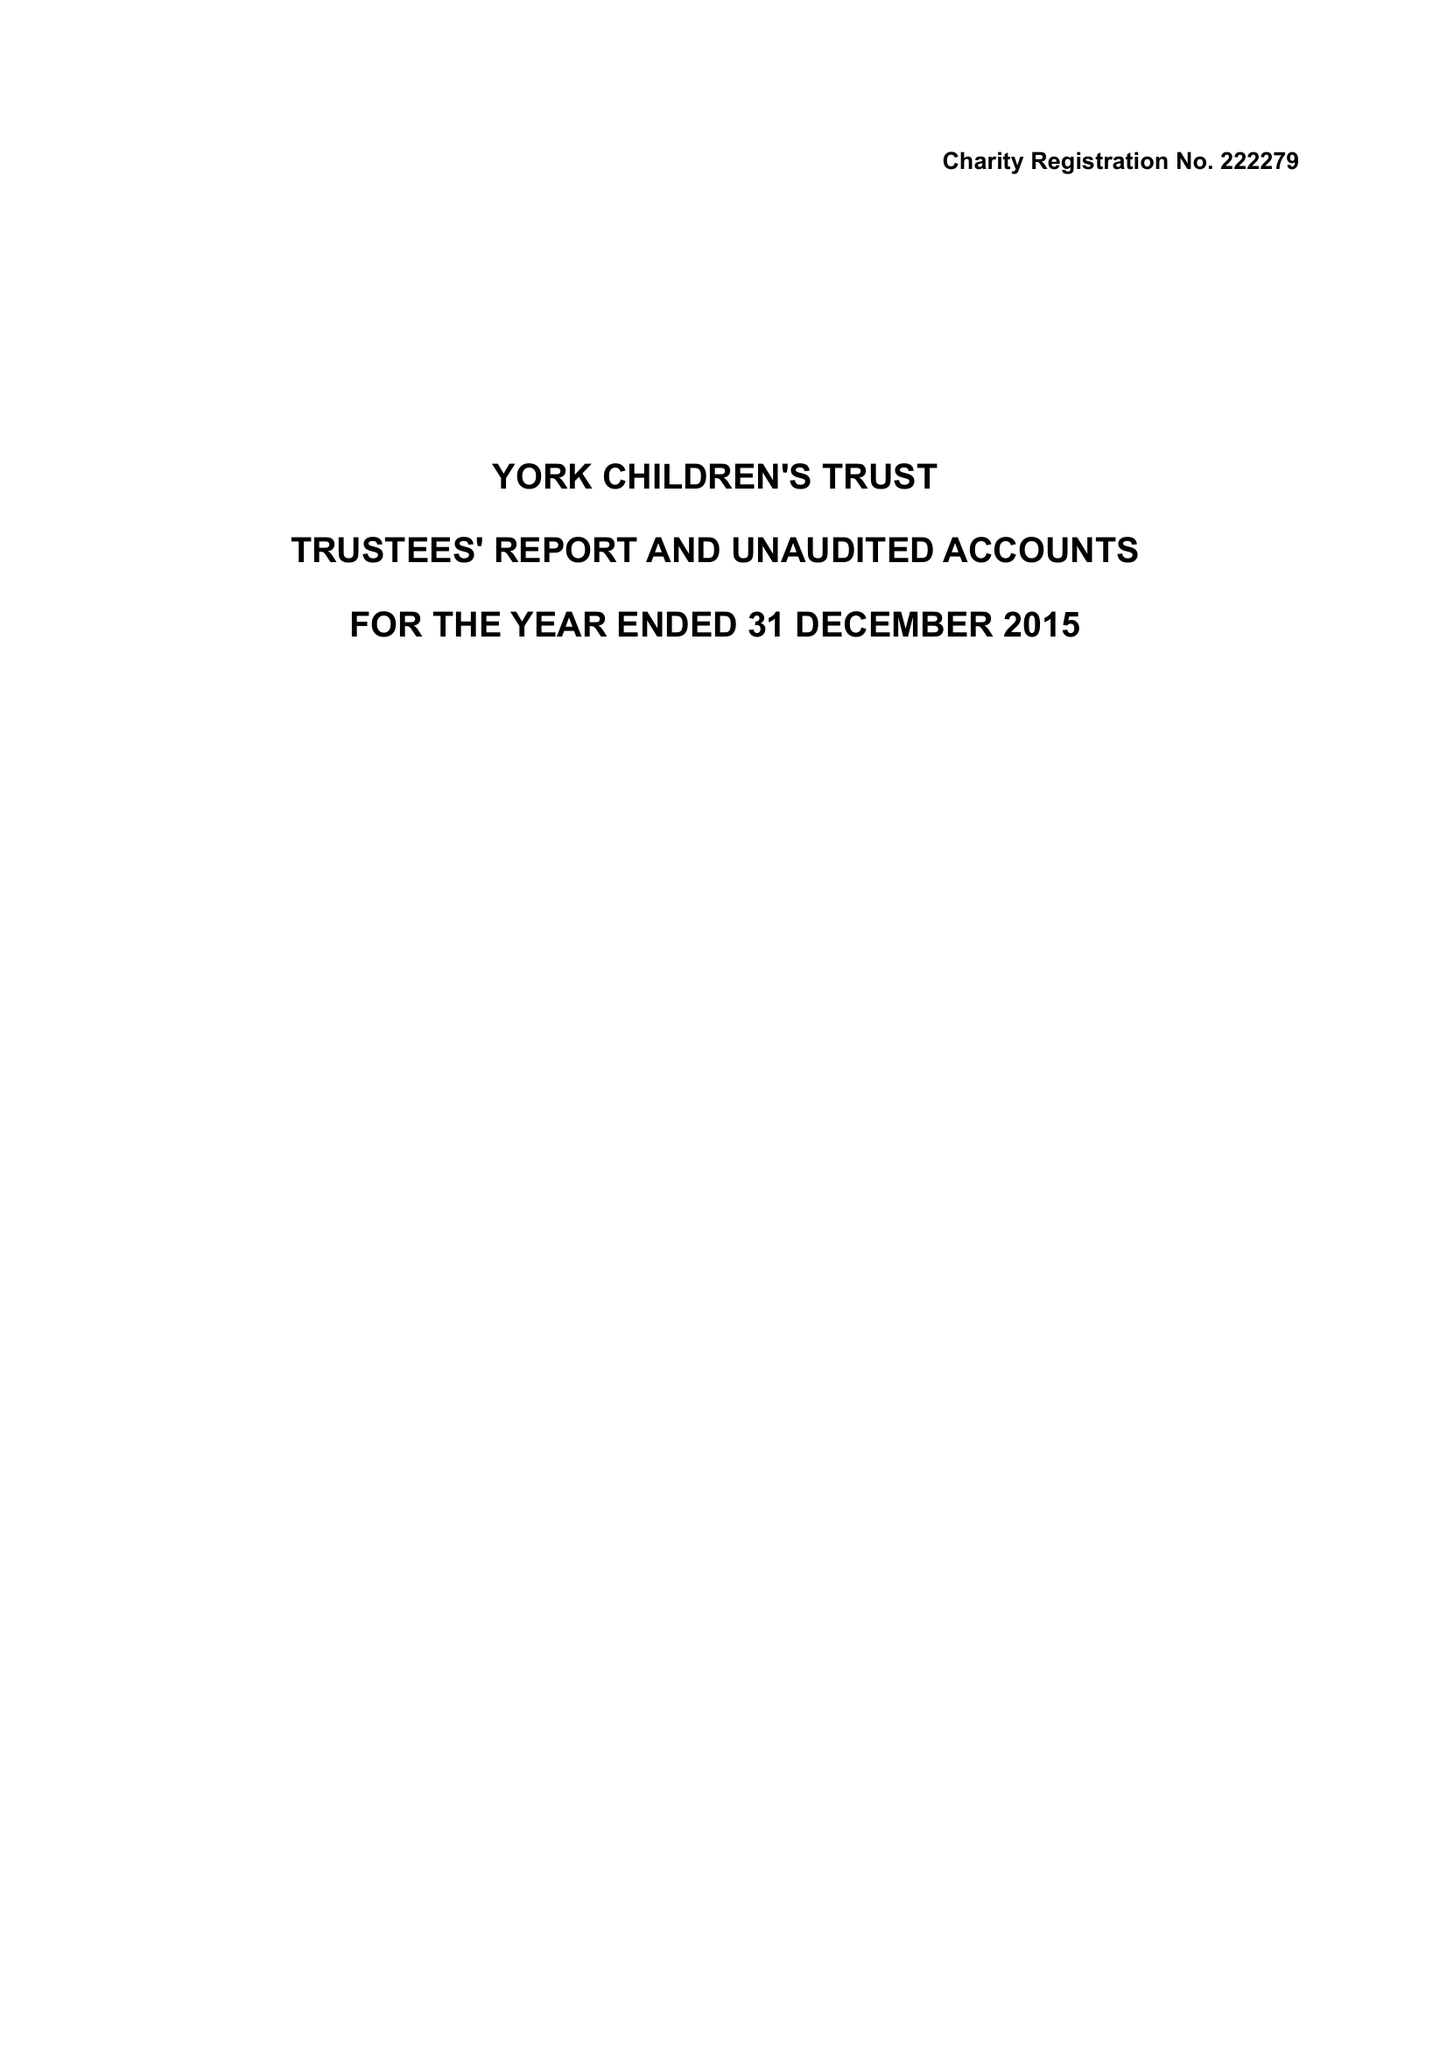What is the value for the charity_name?
Answer the question using a single word or phrase. York Children's Trust 